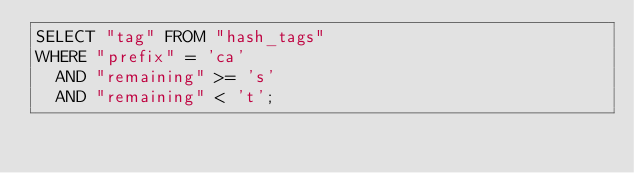<code> <loc_0><loc_0><loc_500><loc_500><_SQL_>SELECT "tag" FROM "hash_tags"
WHERE "prefix" = 'ca'
  AND "remaining" >= 's'
  AND "remaining" < 't';
</code> 